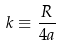<formula> <loc_0><loc_0><loc_500><loc_500>k \equiv \frac { R } { 4 a }</formula> 